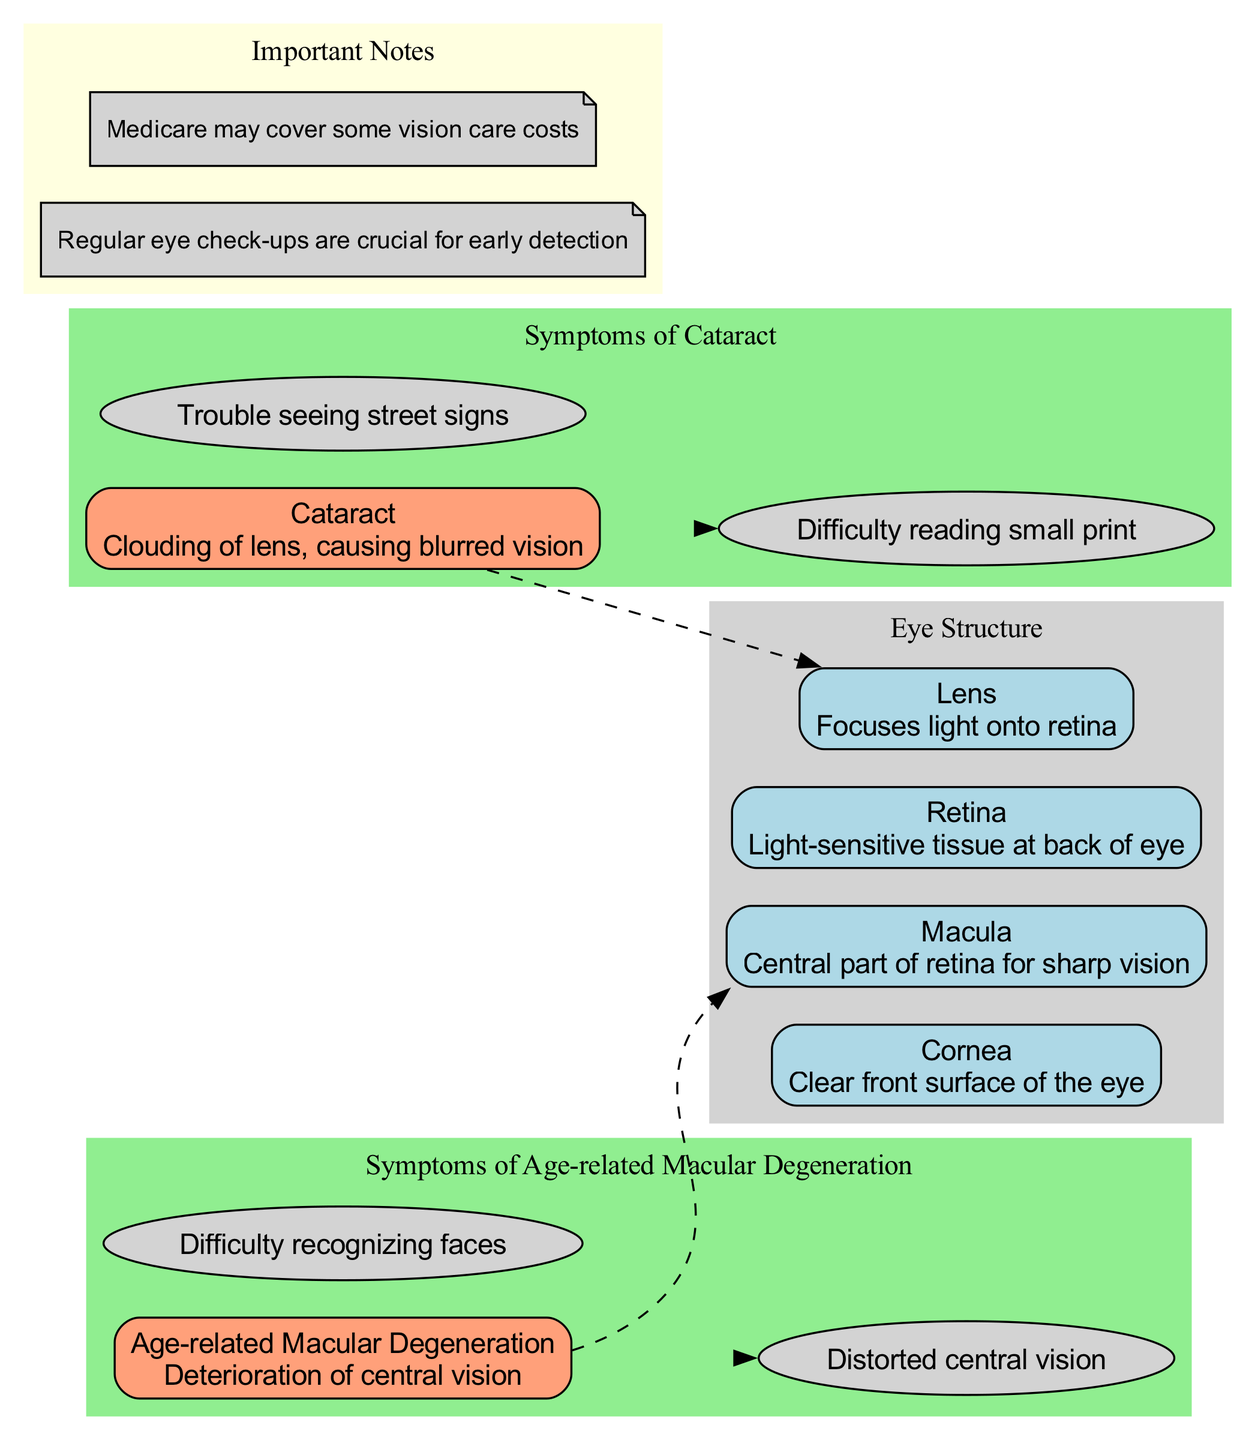What are the main structures of the eye? The diagram lists four main structures: Cornea, Lens, Retina, and Macula. Each structure is labeled and accompanied by a brief description of its function.
Answer: Cornea, Lens, Retina, Macula Where is the lens located in relation to cataracts? The diagram indicates that cataracts occur in the lens of the eye, which is shown with a dashed line connecting the condition to its location.
Answer: Lens What does the macula do? According to the diagram, the macula is described as the central part of the retina responsible for sharp vision, highlighting its function specifically.
Answer: Central part of retina for sharp vision What are the symptoms of cataracts? Observing the diagram, the symptoms listed for cataracts include difficulty reading small print and trouble seeing street signs, shown in a grouped section related to cataracts.
Answer: Difficulty reading small print, Trouble seeing street signs How many age-related conditions are represented in the diagram? The diagram includes two age-related conditions: Cataract and Age-related Macular Degeneration. This can be confirmed by counting the nodes representing these conditions.
Answer: 2 What relationship exists between Age-related Macular Degeneration and the macula? The diagram shows a dashed line connecting Age-related Macular Degeneration to the Macula, indicating that this condition affects that specific part of the eye.
Answer: Affects the Macula What effect does Age-related Macular Degeneration have on vision? The diagram notes that Age-related Macular Degeneration results in distorted central vision and difficulty recognizing faces as the symptoms of this condition.
Answer: Distorted central vision, Difficulty recognizing faces Why are regular eye check-ups important according to the notes? The notes emphasize that regular eye check-ups are crucial for early detection of conditions like cataracts and macular degeneration, highlighting the preventative care aspect.
Answer: For early detection Does Medicare cover vision care costs? The notes mention that Medicare may cover some vision care costs, suggesting financial assistance can be available for eye health.
Answer: Yes, may cover some costs 